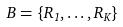<formula> <loc_0><loc_0><loc_500><loc_500>B = \{ R _ { 1 } , \dots , R _ { K } \}</formula> 